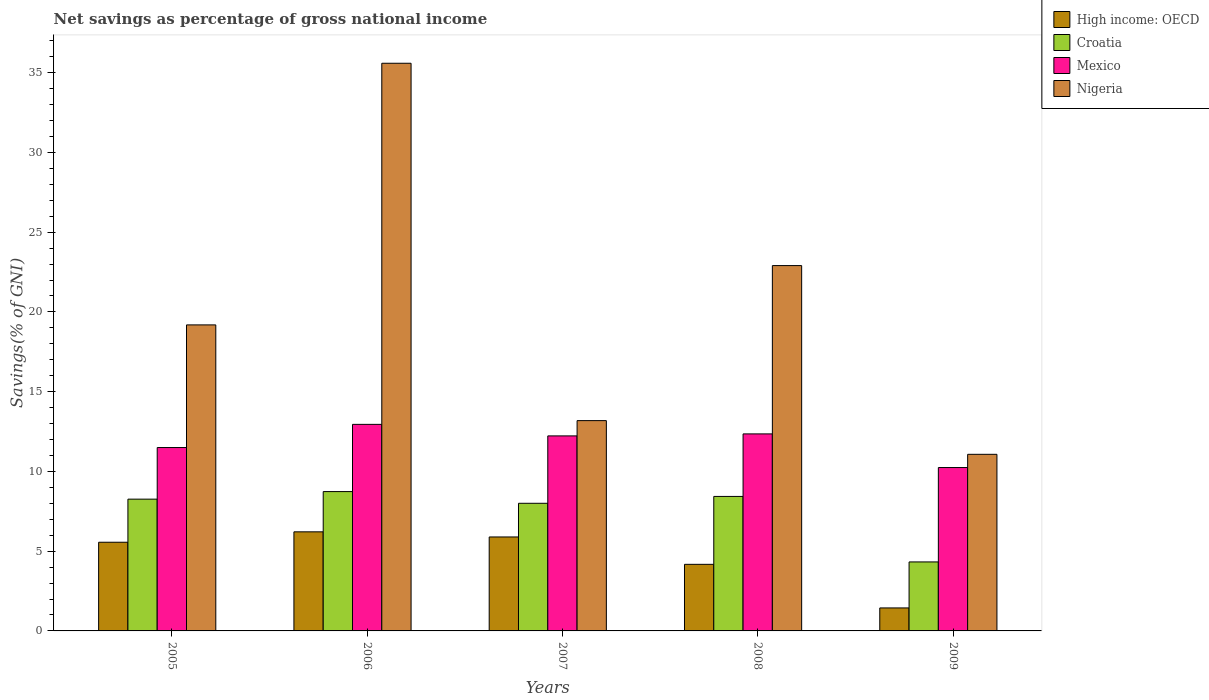How many groups of bars are there?
Give a very brief answer. 5. Are the number of bars per tick equal to the number of legend labels?
Provide a succinct answer. Yes. Are the number of bars on each tick of the X-axis equal?
Your answer should be very brief. Yes. How many bars are there on the 1st tick from the left?
Your answer should be very brief. 4. How many bars are there on the 4th tick from the right?
Provide a short and direct response. 4. What is the total savings in Mexico in 2007?
Give a very brief answer. 12.23. Across all years, what is the maximum total savings in Croatia?
Your answer should be compact. 8.74. Across all years, what is the minimum total savings in Croatia?
Give a very brief answer. 4.33. In which year was the total savings in Mexico maximum?
Offer a very short reply. 2006. In which year was the total savings in Nigeria minimum?
Offer a terse response. 2009. What is the total total savings in Mexico in the graph?
Provide a succinct answer. 59.27. What is the difference between the total savings in High income: OECD in 2005 and that in 2009?
Your answer should be compact. 4.12. What is the difference between the total savings in Mexico in 2007 and the total savings in Nigeria in 2009?
Your response must be concise. 1.16. What is the average total savings in Croatia per year?
Offer a very short reply. 7.55. In the year 2009, what is the difference between the total savings in Nigeria and total savings in High income: OECD?
Offer a terse response. 9.63. In how many years, is the total savings in Nigeria greater than 24 %?
Keep it short and to the point. 1. What is the ratio of the total savings in High income: OECD in 2007 to that in 2008?
Your response must be concise. 1.41. Is the total savings in High income: OECD in 2005 less than that in 2008?
Keep it short and to the point. No. Is the difference between the total savings in Nigeria in 2006 and 2007 greater than the difference between the total savings in High income: OECD in 2006 and 2007?
Provide a succinct answer. Yes. What is the difference between the highest and the second highest total savings in High income: OECD?
Offer a terse response. 0.32. What is the difference between the highest and the lowest total savings in High income: OECD?
Keep it short and to the point. 4.77. What does the 3rd bar from the left in 2008 represents?
Offer a terse response. Mexico. What does the 2nd bar from the right in 2006 represents?
Your response must be concise. Mexico. How many bars are there?
Keep it short and to the point. 20. What is the difference between two consecutive major ticks on the Y-axis?
Your response must be concise. 5. Does the graph contain any zero values?
Offer a very short reply. No. Does the graph contain grids?
Your answer should be compact. No. Where does the legend appear in the graph?
Provide a short and direct response. Top right. What is the title of the graph?
Your answer should be compact. Net savings as percentage of gross national income. What is the label or title of the Y-axis?
Your answer should be very brief. Savings(% of GNI). What is the Savings(% of GNI) of High income: OECD in 2005?
Your answer should be very brief. 5.56. What is the Savings(% of GNI) of Croatia in 2005?
Provide a succinct answer. 8.26. What is the Savings(% of GNI) in Mexico in 2005?
Provide a succinct answer. 11.5. What is the Savings(% of GNI) in Nigeria in 2005?
Your answer should be compact. 19.19. What is the Savings(% of GNI) of High income: OECD in 2006?
Make the answer very short. 6.21. What is the Savings(% of GNI) of Croatia in 2006?
Give a very brief answer. 8.74. What is the Savings(% of GNI) of Mexico in 2006?
Your answer should be compact. 12.95. What is the Savings(% of GNI) in Nigeria in 2006?
Make the answer very short. 35.59. What is the Savings(% of GNI) in High income: OECD in 2007?
Provide a succinct answer. 5.89. What is the Savings(% of GNI) in Croatia in 2007?
Your response must be concise. 8. What is the Savings(% of GNI) of Mexico in 2007?
Ensure brevity in your answer.  12.23. What is the Savings(% of GNI) of Nigeria in 2007?
Offer a terse response. 13.18. What is the Savings(% of GNI) in High income: OECD in 2008?
Keep it short and to the point. 4.17. What is the Savings(% of GNI) of Croatia in 2008?
Make the answer very short. 8.43. What is the Savings(% of GNI) of Mexico in 2008?
Offer a terse response. 12.35. What is the Savings(% of GNI) in Nigeria in 2008?
Your response must be concise. 22.9. What is the Savings(% of GNI) of High income: OECD in 2009?
Offer a terse response. 1.44. What is the Savings(% of GNI) in Croatia in 2009?
Provide a succinct answer. 4.33. What is the Savings(% of GNI) of Mexico in 2009?
Provide a short and direct response. 10.24. What is the Savings(% of GNI) in Nigeria in 2009?
Your answer should be compact. 11.07. Across all years, what is the maximum Savings(% of GNI) of High income: OECD?
Provide a succinct answer. 6.21. Across all years, what is the maximum Savings(% of GNI) of Croatia?
Offer a very short reply. 8.74. Across all years, what is the maximum Savings(% of GNI) of Mexico?
Make the answer very short. 12.95. Across all years, what is the maximum Savings(% of GNI) in Nigeria?
Ensure brevity in your answer.  35.59. Across all years, what is the minimum Savings(% of GNI) in High income: OECD?
Offer a terse response. 1.44. Across all years, what is the minimum Savings(% of GNI) in Croatia?
Your answer should be compact. 4.33. Across all years, what is the minimum Savings(% of GNI) in Mexico?
Offer a terse response. 10.24. Across all years, what is the minimum Savings(% of GNI) of Nigeria?
Ensure brevity in your answer.  11.07. What is the total Savings(% of GNI) of High income: OECD in the graph?
Ensure brevity in your answer.  23.28. What is the total Savings(% of GNI) in Croatia in the graph?
Ensure brevity in your answer.  37.76. What is the total Savings(% of GNI) of Mexico in the graph?
Ensure brevity in your answer.  59.27. What is the total Savings(% of GNI) in Nigeria in the graph?
Your response must be concise. 101.94. What is the difference between the Savings(% of GNI) of High income: OECD in 2005 and that in 2006?
Provide a succinct answer. -0.65. What is the difference between the Savings(% of GNI) in Croatia in 2005 and that in 2006?
Offer a terse response. -0.47. What is the difference between the Savings(% of GNI) of Mexico in 2005 and that in 2006?
Provide a succinct answer. -1.45. What is the difference between the Savings(% of GNI) in Nigeria in 2005 and that in 2006?
Your answer should be compact. -16.4. What is the difference between the Savings(% of GNI) of High income: OECD in 2005 and that in 2007?
Your response must be concise. -0.33. What is the difference between the Savings(% of GNI) of Croatia in 2005 and that in 2007?
Give a very brief answer. 0.26. What is the difference between the Savings(% of GNI) in Mexico in 2005 and that in 2007?
Give a very brief answer. -0.73. What is the difference between the Savings(% of GNI) of Nigeria in 2005 and that in 2007?
Your answer should be compact. 6. What is the difference between the Savings(% of GNI) in High income: OECD in 2005 and that in 2008?
Provide a short and direct response. 1.38. What is the difference between the Savings(% of GNI) in Croatia in 2005 and that in 2008?
Your answer should be very brief. -0.17. What is the difference between the Savings(% of GNI) of Mexico in 2005 and that in 2008?
Ensure brevity in your answer.  -0.86. What is the difference between the Savings(% of GNI) in Nigeria in 2005 and that in 2008?
Your answer should be very brief. -3.72. What is the difference between the Savings(% of GNI) of High income: OECD in 2005 and that in 2009?
Give a very brief answer. 4.12. What is the difference between the Savings(% of GNI) in Croatia in 2005 and that in 2009?
Give a very brief answer. 3.94. What is the difference between the Savings(% of GNI) in Mexico in 2005 and that in 2009?
Your answer should be compact. 1.25. What is the difference between the Savings(% of GNI) of Nigeria in 2005 and that in 2009?
Make the answer very short. 8.11. What is the difference between the Savings(% of GNI) of High income: OECD in 2006 and that in 2007?
Provide a short and direct response. 0.32. What is the difference between the Savings(% of GNI) of Croatia in 2006 and that in 2007?
Offer a very short reply. 0.73. What is the difference between the Savings(% of GNI) in Mexico in 2006 and that in 2007?
Make the answer very short. 0.72. What is the difference between the Savings(% of GNI) of Nigeria in 2006 and that in 2007?
Ensure brevity in your answer.  22.4. What is the difference between the Savings(% of GNI) of High income: OECD in 2006 and that in 2008?
Make the answer very short. 2.04. What is the difference between the Savings(% of GNI) of Croatia in 2006 and that in 2008?
Your answer should be compact. 0.3. What is the difference between the Savings(% of GNI) of Mexico in 2006 and that in 2008?
Provide a short and direct response. 0.6. What is the difference between the Savings(% of GNI) in Nigeria in 2006 and that in 2008?
Ensure brevity in your answer.  12.68. What is the difference between the Savings(% of GNI) of High income: OECD in 2006 and that in 2009?
Make the answer very short. 4.77. What is the difference between the Savings(% of GNI) of Croatia in 2006 and that in 2009?
Offer a very short reply. 4.41. What is the difference between the Savings(% of GNI) of Mexico in 2006 and that in 2009?
Ensure brevity in your answer.  2.71. What is the difference between the Savings(% of GNI) of Nigeria in 2006 and that in 2009?
Give a very brief answer. 24.52. What is the difference between the Savings(% of GNI) in High income: OECD in 2007 and that in 2008?
Keep it short and to the point. 1.72. What is the difference between the Savings(% of GNI) in Croatia in 2007 and that in 2008?
Offer a terse response. -0.43. What is the difference between the Savings(% of GNI) in Mexico in 2007 and that in 2008?
Provide a succinct answer. -0.13. What is the difference between the Savings(% of GNI) in Nigeria in 2007 and that in 2008?
Give a very brief answer. -9.72. What is the difference between the Savings(% of GNI) in High income: OECD in 2007 and that in 2009?
Give a very brief answer. 4.45. What is the difference between the Savings(% of GNI) in Croatia in 2007 and that in 2009?
Your answer should be very brief. 3.68. What is the difference between the Savings(% of GNI) of Mexico in 2007 and that in 2009?
Your answer should be compact. 1.98. What is the difference between the Savings(% of GNI) in Nigeria in 2007 and that in 2009?
Your answer should be compact. 2.11. What is the difference between the Savings(% of GNI) in High income: OECD in 2008 and that in 2009?
Give a very brief answer. 2.73. What is the difference between the Savings(% of GNI) of Croatia in 2008 and that in 2009?
Keep it short and to the point. 4.11. What is the difference between the Savings(% of GNI) in Mexico in 2008 and that in 2009?
Give a very brief answer. 2.11. What is the difference between the Savings(% of GNI) in Nigeria in 2008 and that in 2009?
Your response must be concise. 11.83. What is the difference between the Savings(% of GNI) in High income: OECD in 2005 and the Savings(% of GNI) in Croatia in 2006?
Provide a short and direct response. -3.18. What is the difference between the Savings(% of GNI) of High income: OECD in 2005 and the Savings(% of GNI) of Mexico in 2006?
Provide a succinct answer. -7.39. What is the difference between the Savings(% of GNI) of High income: OECD in 2005 and the Savings(% of GNI) of Nigeria in 2006?
Provide a short and direct response. -30.03. What is the difference between the Savings(% of GNI) in Croatia in 2005 and the Savings(% of GNI) in Mexico in 2006?
Your answer should be very brief. -4.69. What is the difference between the Savings(% of GNI) of Croatia in 2005 and the Savings(% of GNI) of Nigeria in 2006?
Offer a very short reply. -27.33. What is the difference between the Savings(% of GNI) of Mexico in 2005 and the Savings(% of GNI) of Nigeria in 2006?
Provide a short and direct response. -24.09. What is the difference between the Savings(% of GNI) in High income: OECD in 2005 and the Savings(% of GNI) in Croatia in 2007?
Give a very brief answer. -2.44. What is the difference between the Savings(% of GNI) in High income: OECD in 2005 and the Savings(% of GNI) in Mexico in 2007?
Offer a very short reply. -6.67. What is the difference between the Savings(% of GNI) of High income: OECD in 2005 and the Savings(% of GNI) of Nigeria in 2007?
Provide a short and direct response. -7.63. What is the difference between the Savings(% of GNI) in Croatia in 2005 and the Savings(% of GNI) in Mexico in 2007?
Offer a terse response. -3.97. What is the difference between the Savings(% of GNI) in Croatia in 2005 and the Savings(% of GNI) in Nigeria in 2007?
Provide a short and direct response. -4.92. What is the difference between the Savings(% of GNI) in Mexico in 2005 and the Savings(% of GNI) in Nigeria in 2007?
Your answer should be compact. -1.69. What is the difference between the Savings(% of GNI) in High income: OECD in 2005 and the Savings(% of GNI) in Croatia in 2008?
Provide a short and direct response. -2.87. What is the difference between the Savings(% of GNI) in High income: OECD in 2005 and the Savings(% of GNI) in Mexico in 2008?
Keep it short and to the point. -6.79. What is the difference between the Savings(% of GNI) in High income: OECD in 2005 and the Savings(% of GNI) in Nigeria in 2008?
Give a very brief answer. -17.34. What is the difference between the Savings(% of GNI) of Croatia in 2005 and the Savings(% of GNI) of Mexico in 2008?
Give a very brief answer. -4.09. What is the difference between the Savings(% of GNI) in Croatia in 2005 and the Savings(% of GNI) in Nigeria in 2008?
Ensure brevity in your answer.  -14.64. What is the difference between the Savings(% of GNI) of Mexico in 2005 and the Savings(% of GNI) of Nigeria in 2008?
Your answer should be very brief. -11.41. What is the difference between the Savings(% of GNI) of High income: OECD in 2005 and the Savings(% of GNI) of Croatia in 2009?
Your response must be concise. 1.23. What is the difference between the Savings(% of GNI) of High income: OECD in 2005 and the Savings(% of GNI) of Mexico in 2009?
Your answer should be very brief. -4.68. What is the difference between the Savings(% of GNI) of High income: OECD in 2005 and the Savings(% of GNI) of Nigeria in 2009?
Your response must be concise. -5.51. What is the difference between the Savings(% of GNI) of Croatia in 2005 and the Savings(% of GNI) of Mexico in 2009?
Provide a succinct answer. -1.98. What is the difference between the Savings(% of GNI) in Croatia in 2005 and the Savings(% of GNI) in Nigeria in 2009?
Ensure brevity in your answer.  -2.81. What is the difference between the Savings(% of GNI) of Mexico in 2005 and the Savings(% of GNI) of Nigeria in 2009?
Your answer should be compact. 0.43. What is the difference between the Savings(% of GNI) of High income: OECD in 2006 and the Savings(% of GNI) of Croatia in 2007?
Offer a terse response. -1.79. What is the difference between the Savings(% of GNI) in High income: OECD in 2006 and the Savings(% of GNI) in Mexico in 2007?
Provide a short and direct response. -6.02. What is the difference between the Savings(% of GNI) in High income: OECD in 2006 and the Savings(% of GNI) in Nigeria in 2007?
Your answer should be very brief. -6.97. What is the difference between the Savings(% of GNI) in Croatia in 2006 and the Savings(% of GNI) in Mexico in 2007?
Make the answer very short. -3.49. What is the difference between the Savings(% of GNI) in Croatia in 2006 and the Savings(% of GNI) in Nigeria in 2007?
Make the answer very short. -4.45. What is the difference between the Savings(% of GNI) of Mexico in 2006 and the Savings(% of GNI) of Nigeria in 2007?
Your answer should be compact. -0.23. What is the difference between the Savings(% of GNI) of High income: OECD in 2006 and the Savings(% of GNI) of Croatia in 2008?
Provide a succinct answer. -2.22. What is the difference between the Savings(% of GNI) of High income: OECD in 2006 and the Savings(% of GNI) of Mexico in 2008?
Ensure brevity in your answer.  -6.14. What is the difference between the Savings(% of GNI) in High income: OECD in 2006 and the Savings(% of GNI) in Nigeria in 2008?
Your response must be concise. -16.69. What is the difference between the Savings(% of GNI) of Croatia in 2006 and the Savings(% of GNI) of Mexico in 2008?
Offer a terse response. -3.62. What is the difference between the Savings(% of GNI) of Croatia in 2006 and the Savings(% of GNI) of Nigeria in 2008?
Give a very brief answer. -14.17. What is the difference between the Savings(% of GNI) in Mexico in 2006 and the Savings(% of GNI) in Nigeria in 2008?
Provide a short and direct response. -9.95. What is the difference between the Savings(% of GNI) in High income: OECD in 2006 and the Savings(% of GNI) in Croatia in 2009?
Make the answer very short. 1.89. What is the difference between the Savings(% of GNI) of High income: OECD in 2006 and the Savings(% of GNI) of Mexico in 2009?
Provide a short and direct response. -4.03. What is the difference between the Savings(% of GNI) in High income: OECD in 2006 and the Savings(% of GNI) in Nigeria in 2009?
Offer a terse response. -4.86. What is the difference between the Savings(% of GNI) of Croatia in 2006 and the Savings(% of GNI) of Mexico in 2009?
Provide a succinct answer. -1.51. What is the difference between the Savings(% of GNI) in Croatia in 2006 and the Savings(% of GNI) in Nigeria in 2009?
Give a very brief answer. -2.34. What is the difference between the Savings(% of GNI) in Mexico in 2006 and the Savings(% of GNI) in Nigeria in 2009?
Your answer should be compact. 1.88. What is the difference between the Savings(% of GNI) of High income: OECD in 2007 and the Savings(% of GNI) of Croatia in 2008?
Provide a short and direct response. -2.54. What is the difference between the Savings(% of GNI) of High income: OECD in 2007 and the Savings(% of GNI) of Mexico in 2008?
Give a very brief answer. -6.46. What is the difference between the Savings(% of GNI) of High income: OECD in 2007 and the Savings(% of GNI) of Nigeria in 2008?
Your response must be concise. -17.01. What is the difference between the Savings(% of GNI) in Croatia in 2007 and the Savings(% of GNI) in Mexico in 2008?
Keep it short and to the point. -4.35. What is the difference between the Savings(% of GNI) in Croatia in 2007 and the Savings(% of GNI) in Nigeria in 2008?
Your answer should be compact. -14.9. What is the difference between the Savings(% of GNI) in Mexico in 2007 and the Savings(% of GNI) in Nigeria in 2008?
Ensure brevity in your answer.  -10.68. What is the difference between the Savings(% of GNI) of High income: OECD in 2007 and the Savings(% of GNI) of Croatia in 2009?
Your answer should be compact. 1.56. What is the difference between the Savings(% of GNI) of High income: OECD in 2007 and the Savings(% of GNI) of Mexico in 2009?
Offer a terse response. -4.35. What is the difference between the Savings(% of GNI) of High income: OECD in 2007 and the Savings(% of GNI) of Nigeria in 2009?
Provide a short and direct response. -5.18. What is the difference between the Savings(% of GNI) of Croatia in 2007 and the Savings(% of GNI) of Mexico in 2009?
Provide a short and direct response. -2.24. What is the difference between the Savings(% of GNI) in Croatia in 2007 and the Savings(% of GNI) in Nigeria in 2009?
Your response must be concise. -3.07. What is the difference between the Savings(% of GNI) of Mexico in 2007 and the Savings(% of GNI) of Nigeria in 2009?
Offer a terse response. 1.16. What is the difference between the Savings(% of GNI) of High income: OECD in 2008 and the Savings(% of GNI) of Croatia in 2009?
Keep it short and to the point. -0.15. What is the difference between the Savings(% of GNI) in High income: OECD in 2008 and the Savings(% of GNI) in Mexico in 2009?
Offer a terse response. -6.07. What is the difference between the Savings(% of GNI) of High income: OECD in 2008 and the Savings(% of GNI) of Nigeria in 2009?
Provide a short and direct response. -6.9. What is the difference between the Savings(% of GNI) in Croatia in 2008 and the Savings(% of GNI) in Mexico in 2009?
Your answer should be very brief. -1.81. What is the difference between the Savings(% of GNI) of Croatia in 2008 and the Savings(% of GNI) of Nigeria in 2009?
Give a very brief answer. -2.64. What is the difference between the Savings(% of GNI) in Mexico in 2008 and the Savings(% of GNI) in Nigeria in 2009?
Offer a terse response. 1.28. What is the average Savings(% of GNI) of High income: OECD per year?
Ensure brevity in your answer.  4.66. What is the average Savings(% of GNI) in Croatia per year?
Your answer should be very brief. 7.55. What is the average Savings(% of GNI) of Mexico per year?
Give a very brief answer. 11.85. What is the average Savings(% of GNI) in Nigeria per year?
Offer a terse response. 20.39. In the year 2005, what is the difference between the Savings(% of GNI) of High income: OECD and Savings(% of GNI) of Croatia?
Your answer should be very brief. -2.7. In the year 2005, what is the difference between the Savings(% of GNI) of High income: OECD and Savings(% of GNI) of Mexico?
Your response must be concise. -5.94. In the year 2005, what is the difference between the Savings(% of GNI) in High income: OECD and Savings(% of GNI) in Nigeria?
Offer a very short reply. -13.63. In the year 2005, what is the difference between the Savings(% of GNI) of Croatia and Savings(% of GNI) of Mexico?
Your response must be concise. -3.24. In the year 2005, what is the difference between the Savings(% of GNI) of Croatia and Savings(% of GNI) of Nigeria?
Your answer should be very brief. -10.92. In the year 2005, what is the difference between the Savings(% of GNI) of Mexico and Savings(% of GNI) of Nigeria?
Offer a very short reply. -7.69. In the year 2006, what is the difference between the Savings(% of GNI) in High income: OECD and Savings(% of GNI) in Croatia?
Offer a very short reply. -2.52. In the year 2006, what is the difference between the Savings(% of GNI) in High income: OECD and Savings(% of GNI) in Mexico?
Offer a very short reply. -6.74. In the year 2006, what is the difference between the Savings(% of GNI) of High income: OECD and Savings(% of GNI) of Nigeria?
Ensure brevity in your answer.  -29.38. In the year 2006, what is the difference between the Savings(% of GNI) in Croatia and Savings(% of GNI) in Mexico?
Your response must be concise. -4.21. In the year 2006, what is the difference between the Savings(% of GNI) in Croatia and Savings(% of GNI) in Nigeria?
Offer a very short reply. -26.85. In the year 2006, what is the difference between the Savings(% of GNI) of Mexico and Savings(% of GNI) of Nigeria?
Your answer should be very brief. -22.64. In the year 2007, what is the difference between the Savings(% of GNI) in High income: OECD and Savings(% of GNI) in Croatia?
Keep it short and to the point. -2.11. In the year 2007, what is the difference between the Savings(% of GNI) of High income: OECD and Savings(% of GNI) of Mexico?
Offer a very short reply. -6.34. In the year 2007, what is the difference between the Savings(% of GNI) of High income: OECD and Savings(% of GNI) of Nigeria?
Ensure brevity in your answer.  -7.29. In the year 2007, what is the difference between the Savings(% of GNI) of Croatia and Savings(% of GNI) of Mexico?
Ensure brevity in your answer.  -4.23. In the year 2007, what is the difference between the Savings(% of GNI) in Croatia and Savings(% of GNI) in Nigeria?
Offer a terse response. -5.18. In the year 2007, what is the difference between the Savings(% of GNI) of Mexico and Savings(% of GNI) of Nigeria?
Your answer should be compact. -0.96. In the year 2008, what is the difference between the Savings(% of GNI) in High income: OECD and Savings(% of GNI) in Croatia?
Give a very brief answer. -4.26. In the year 2008, what is the difference between the Savings(% of GNI) in High income: OECD and Savings(% of GNI) in Mexico?
Give a very brief answer. -8.18. In the year 2008, what is the difference between the Savings(% of GNI) of High income: OECD and Savings(% of GNI) of Nigeria?
Ensure brevity in your answer.  -18.73. In the year 2008, what is the difference between the Savings(% of GNI) in Croatia and Savings(% of GNI) in Mexico?
Ensure brevity in your answer.  -3.92. In the year 2008, what is the difference between the Savings(% of GNI) of Croatia and Savings(% of GNI) of Nigeria?
Provide a short and direct response. -14.47. In the year 2008, what is the difference between the Savings(% of GNI) in Mexico and Savings(% of GNI) in Nigeria?
Keep it short and to the point. -10.55. In the year 2009, what is the difference between the Savings(% of GNI) of High income: OECD and Savings(% of GNI) of Croatia?
Make the answer very short. -2.88. In the year 2009, what is the difference between the Savings(% of GNI) in High income: OECD and Savings(% of GNI) in Mexico?
Your answer should be compact. -8.8. In the year 2009, what is the difference between the Savings(% of GNI) of High income: OECD and Savings(% of GNI) of Nigeria?
Your response must be concise. -9.63. In the year 2009, what is the difference between the Savings(% of GNI) of Croatia and Savings(% of GNI) of Mexico?
Make the answer very short. -5.92. In the year 2009, what is the difference between the Savings(% of GNI) in Croatia and Savings(% of GNI) in Nigeria?
Keep it short and to the point. -6.75. In the year 2009, what is the difference between the Savings(% of GNI) of Mexico and Savings(% of GNI) of Nigeria?
Your response must be concise. -0.83. What is the ratio of the Savings(% of GNI) of High income: OECD in 2005 to that in 2006?
Your answer should be very brief. 0.9. What is the ratio of the Savings(% of GNI) of Croatia in 2005 to that in 2006?
Your answer should be compact. 0.95. What is the ratio of the Savings(% of GNI) of Mexico in 2005 to that in 2006?
Your answer should be compact. 0.89. What is the ratio of the Savings(% of GNI) in Nigeria in 2005 to that in 2006?
Keep it short and to the point. 0.54. What is the ratio of the Savings(% of GNI) in High income: OECD in 2005 to that in 2007?
Offer a very short reply. 0.94. What is the ratio of the Savings(% of GNI) in Croatia in 2005 to that in 2007?
Your answer should be compact. 1.03. What is the ratio of the Savings(% of GNI) in Mexico in 2005 to that in 2007?
Your answer should be compact. 0.94. What is the ratio of the Savings(% of GNI) in Nigeria in 2005 to that in 2007?
Keep it short and to the point. 1.46. What is the ratio of the Savings(% of GNI) in High income: OECD in 2005 to that in 2008?
Provide a short and direct response. 1.33. What is the ratio of the Savings(% of GNI) in Croatia in 2005 to that in 2008?
Offer a terse response. 0.98. What is the ratio of the Savings(% of GNI) of Mexico in 2005 to that in 2008?
Offer a terse response. 0.93. What is the ratio of the Savings(% of GNI) in Nigeria in 2005 to that in 2008?
Your response must be concise. 0.84. What is the ratio of the Savings(% of GNI) of High income: OECD in 2005 to that in 2009?
Offer a terse response. 3.86. What is the ratio of the Savings(% of GNI) of Croatia in 2005 to that in 2009?
Offer a very short reply. 1.91. What is the ratio of the Savings(% of GNI) in Mexico in 2005 to that in 2009?
Make the answer very short. 1.12. What is the ratio of the Savings(% of GNI) in Nigeria in 2005 to that in 2009?
Provide a succinct answer. 1.73. What is the ratio of the Savings(% of GNI) of High income: OECD in 2006 to that in 2007?
Provide a short and direct response. 1.05. What is the ratio of the Savings(% of GNI) in Croatia in 2006 to that in 2007?
Your answer should be compact. 1.09. What is the ratio of the Savings(% of GNI) of Mexico in 2006 to that in 2007?
Offer a very short reply. 1.06. What is the ratio of the Savings(% of GNI) in Nigeria in 2006 to that in 2007?
Provide a short and direct response. 2.7. What is the ratio of the Savings(% of GNI) in High income: OECD in 2006 to that in 2008?
Offer a terse response. 1.49. What is the ratio of the Savings(% of GNI) of Croatia in 2006 to that in 2008?
Give a very brief answer. 1.04. What is the ratio of the Savings(% of GNI) in Mexico in 2006 to that in 2008?
Your answer should be compact. 1.05. What is the ratio of the Savings(% of GNI) in Nigeria in 2006 to that in 2008?
Provide a succinct answer. 1.55. What is the ratio of the Savings(% of GNI) in High income: OECD in 2006 to that in 2009?
Ensure brevity in your answer.  4.31. What is the ratio of the Savings(% of GNI) of Croatia in 2006 to that in 2009?
Ensure brevity in your answer.  2.02. What is the ratio of the Savings(% of GNI) in Mexico in 2006 to that in 2009?
Provide a short and direct response. 1.26. What is the ratio of the Savings(% of GNI) of Nigeria in 2006 to that in 2009?
Your answer should be very brief. 3.21. What is the ratio of the Savings(% of GNI) in High income: OECD in 2007 to that in 2008?
Offer a very short reply. 1.41. What is the ratio of the Savings(% of GNI) of Croatia in 2007 to that in 2008?
Your answer should be very brief. 0.95. What is the ratio of the Savings(% of GNI) of Mexico in 2007 to that in 2008?
Provide a short and direct response. 0.99. What is the ratio of the Savings(% of GNI) of Nigeria in 2007 to that in 2008?
Keep it short and to the point. 0.58. What is the ratio of the Savings(% of GNI) in High income: OECD in 2007 to that in 2009?
Make the answer very short. 4.09. What is the ratio of the Savings(% of GNI) of Croatia in 2007 to that in 2009?
Provide a succinct answer. 1.85. What is the ratio of the Savings(% of GNI) in Mexico in 2007 to that in 2009?
Keep it short and to the point. 1.19. What is the ratio of the Savings(% of GNI) of Nigeria in 2007 to that in 2009?
Your answer should be compact. 1.19. What is the ratio of the Savings(% of GNI) in High income: OECD in 2008 to that in 2009?
Ensure brevity in your answer.  2.9. What is the ratio of the Savings(% of GNI) of Croatia in 2008 to that in 2009?
Give a very brief answer. 1.95. What is the ratio of the Savings(% of GNI) in Mexico in 2008 to that in 2009?
Provide a succinct answer. 1.21. What is the ratio of the Savings(% of GNI) in Nigeria in 2008 to that in 2009?
Ensure brevity in your answer.  2.07. What is the difference between the highest and the second highest Savings(% of GNI) in High income: OECD?
Your answer should be compact. 0.32. What is the difference between the highest and the second highest Savings(% of GNI) of Croatia?
Keep it short and to the point. 0.3. What is the difference between the highest and the second highest Savings(% of GNI) of Mexico?
Ensure brevity in your answer.  0.6. What is the difference between the highest and the second highest Savings(% of GNI) of Nigeria?
Your response must be concise. 12.68. What is the difference between the highest and the lowest Savings(% of GNI) of High income: OECD?
Your answer should be very brief. 4.77. What is the difference between the highest and the lowest Savings(% of GNI) of Croatia?
Offer a terse response. 4.41. What is the difference between the highest and the lowest Savings(% of GNI) of Mexico?
Your answer should be compact. 2.71. What is the difference between the highest and the lowest Savings(% of GNI) in Nigeria?
Offer a very short reply. 24.52. 